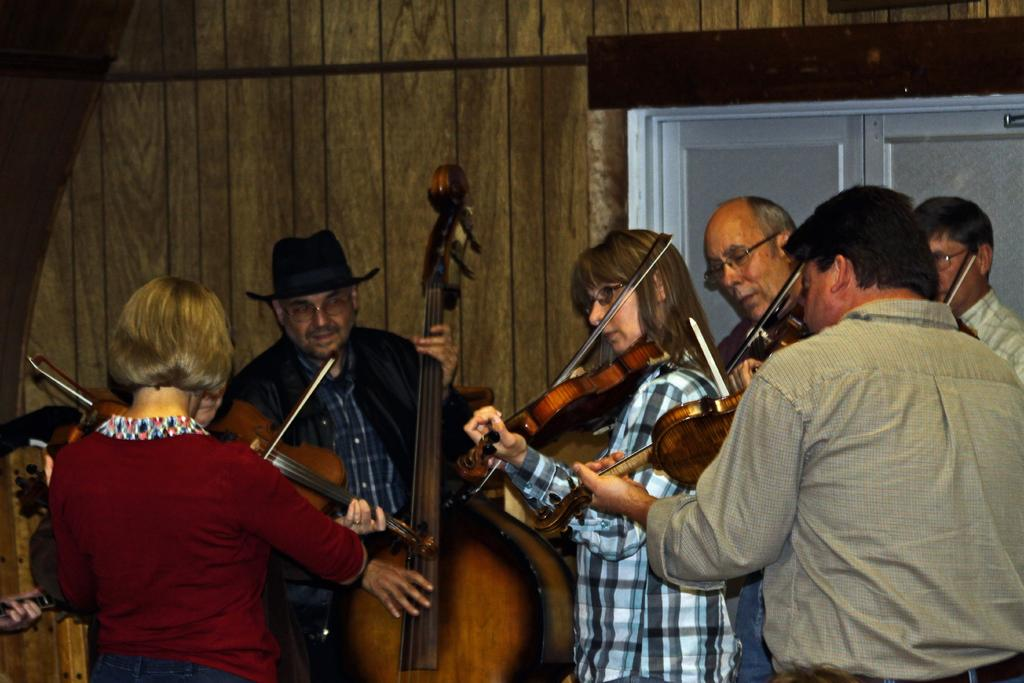How many people are present in the image? There are 2 women and 4 men in the image, making a total of 6 people. What are the individuals in the image doing? All the individuals are holding musical instruments. What can be seen in the background of the image? There is a wall in the background of the image. What type of soup is being cooked by one of the women in the image? There is no woman cooking soup in the image; all the individuals are holding musical instruments. What color is the cook's apron in the image? There is no cook or apron present in the image. 